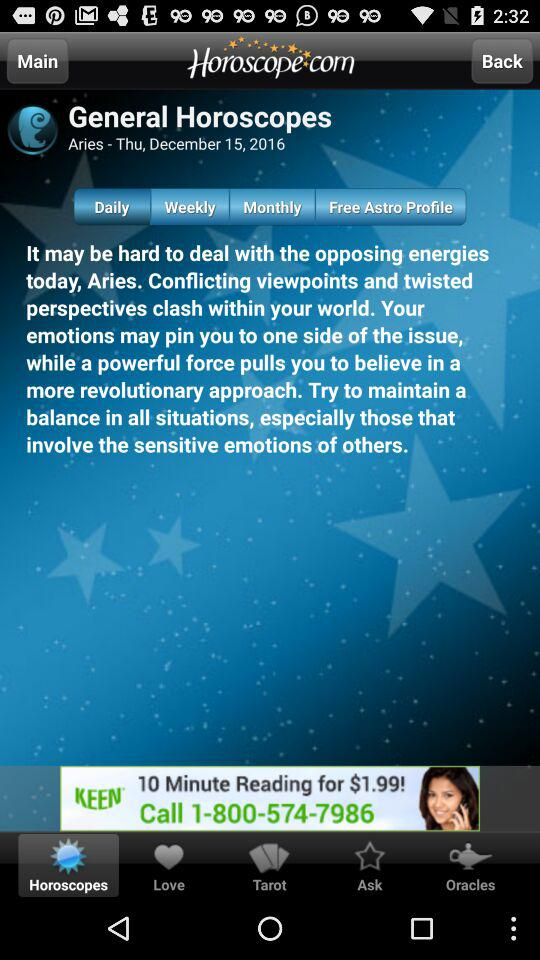The general horoscope is of what date? The date is Thursday, December 15, 2016. 